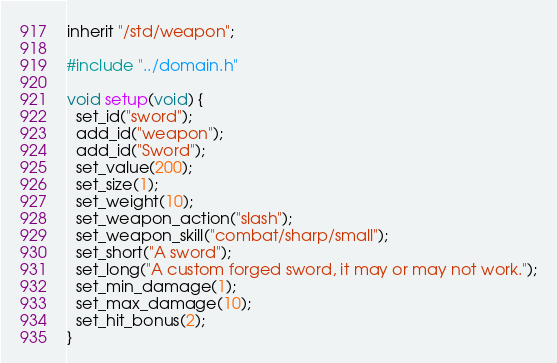Convert code to text. <code><loc_0><loc_0><loc_500><loc_500><_C_>inherit "/std/weapon";

#include "../domain.h"

void setup(void) {
  set_id("sword");
  add_id("weapon");
  add_id("Sword");
  set_value(200);
  set_size(1);
  set_weight(10);
  set_weapon_action("slash");
  set_weapon_skill("combat/sharp/small");
  set_short("A sword");
  set_long("A custom forged sword, it may or may not work.");
  set_min_damage(1);
  set_max_damage(10);
  set_hit_bonus(2);
}
</code> 